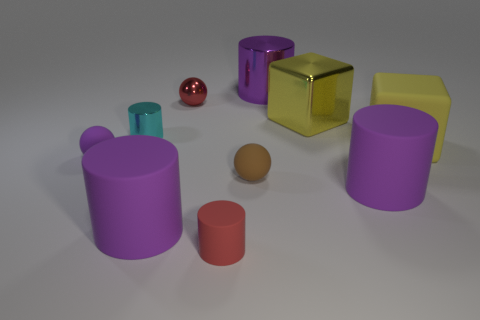Subtract all small red cylinders. How many cylinders are left? 4 Subtract all red spheres. How many spheres are left? 2 Subtract all yellow blocks. How many purple cylinders are left? 3 Subtract all spheres. How many objects are left? 7 Subtract 1 cylinders. How many cylinders are left? 4 Subtract 1 red spheres. How many objects are left? 9 Subtract all blue blocks. Subtract all gray spheres. How many blocks are left? 2 Subtract all large purple shiny cylinders. Subtract all small purple spheres. How many objects are left? 8 Add 7 cyan metal things. How many cyan metal things are left? 8 Add 9 red shiny cylinders. How many red shiny cylinders exist? 9 